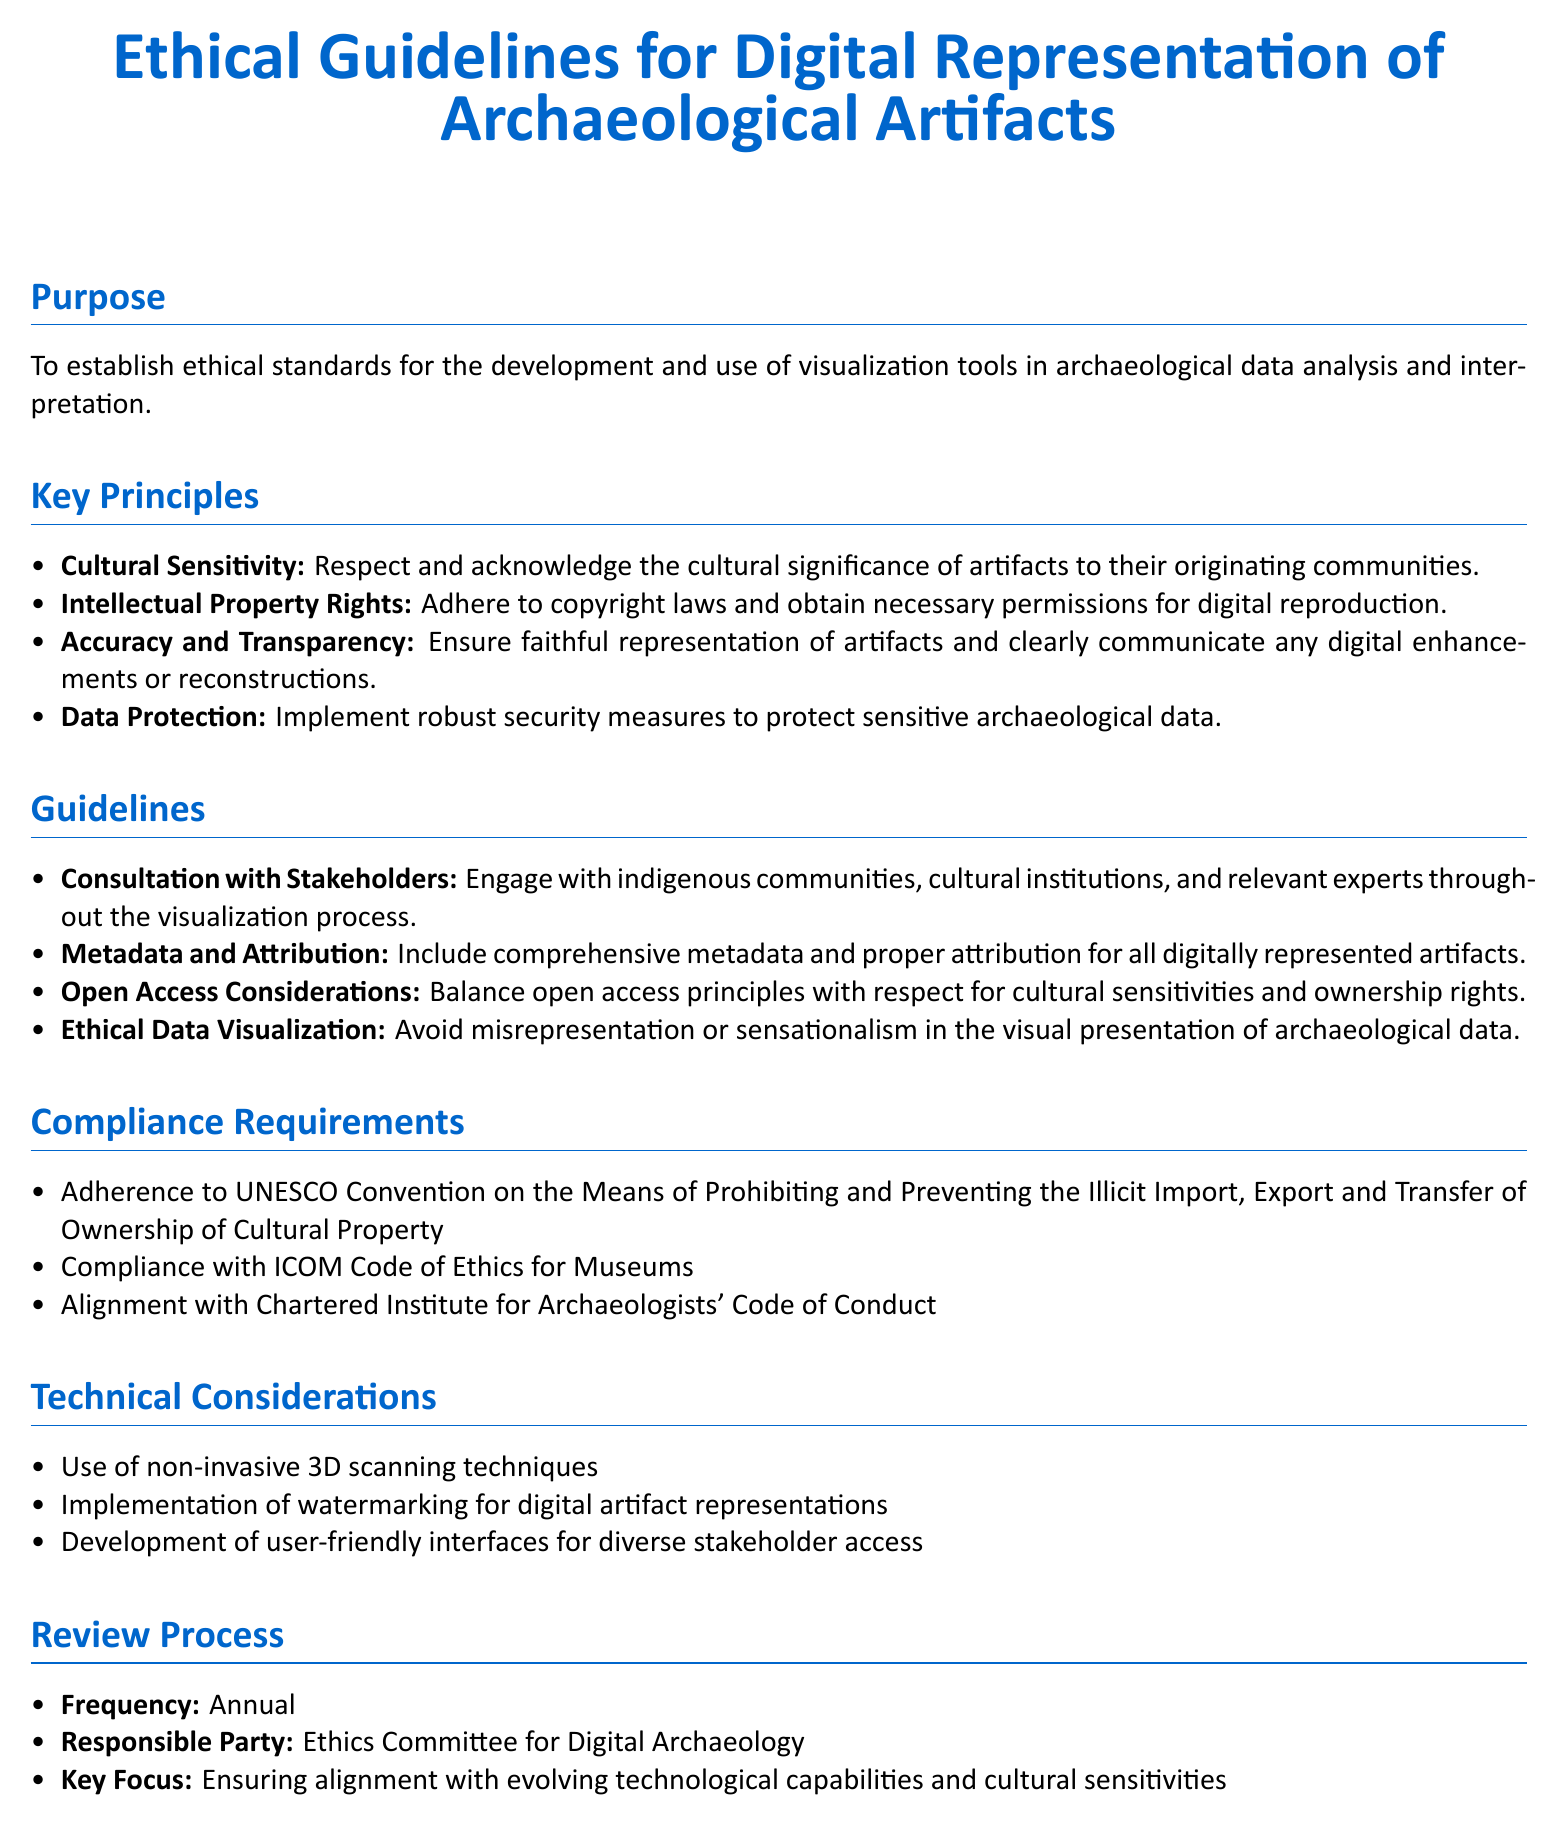What is the purpose of the document? The purpose is to establish ethical standards for the development and use of visualization tools in archaeological data analysis and interpretation.
Answer: To establish ethical standards for the development and use of visualization tools in archaeological data analysis and interpretation What is one key principle of the guidelines? The key principle includes cultural sensitivity, which is one of the main focuses outlined in the document.
Answer: Cultural Sensitivity Who is responsible for the review process? The document specifies that the Ethics Committee for Digital Archaeology is responsible for the review process.
Answer: Ethics Committee for Digital Archaeology What is the frequency of the review process? The document states that the review process occurs annually.
Answer: Annual What technology is recommended for data visualization? Non-invasive 3D scanning techniques are listed as a technical consideration for data visualization.
Answer: Non-invasive 3D scanning techniques What does the document say about metadata? The guidelines emphasize that comprehensive metadata and proper attribution should be included for all digitally represented artifacts.
Answer: Include comprehensive metadata and proper attribution Which code must be complied with according to the document? The ICOM Code of Ethics for Museums is one of the compliance requirements stated in the document.
Answer: ICOM Code of Ethics for Museums What is emphasized under ethical data visualization? The document indicates that misrepresentation or sensationalism should be avoided in the visual presentation of archaeological data.
Answer: Avoid misrepresentation or sensationalism 